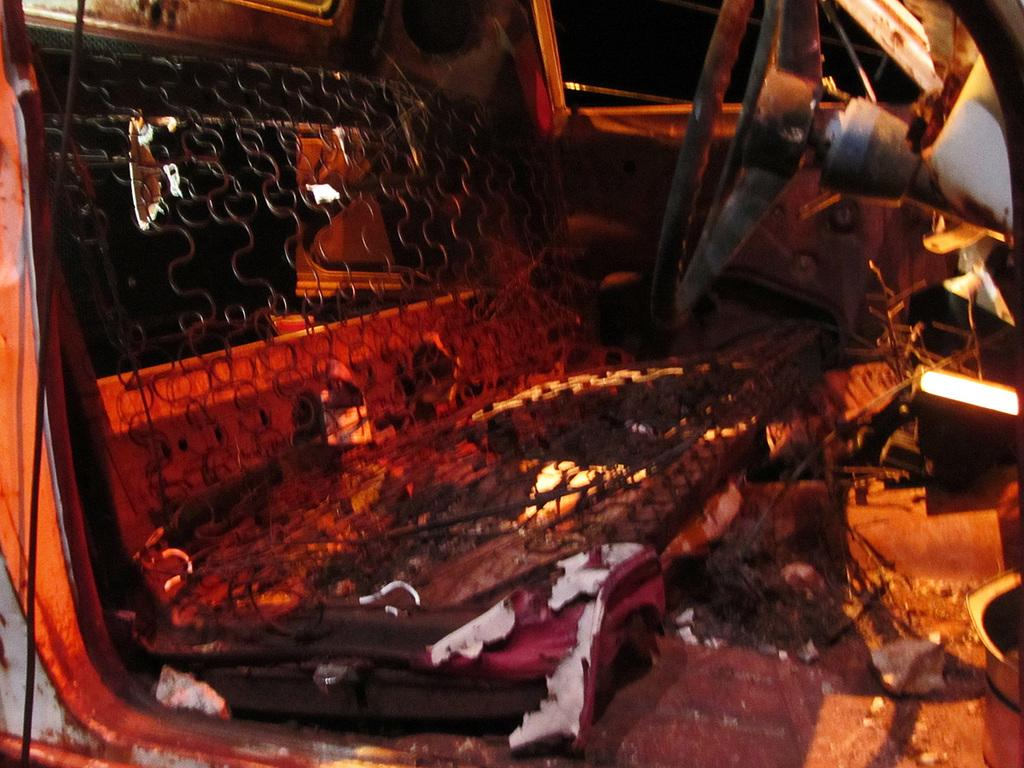What type of space is depicted in the image? The image shows an inside view of a vehicle. What can be seen on the left side of the vehicle? There is a seat on the left side of the vehicle. What is located on the right side of the vehicle? A steering wheel is present on the right side of the vehicle. What feature of the vehicle can be seen in the background of the image? There is a door visible in the background of the image. What type of paper is being polished on the seat in the image? There is no paper or polishing activity present in the image; it shows an inside view of a vehicle with a seat and a steering wheel. 